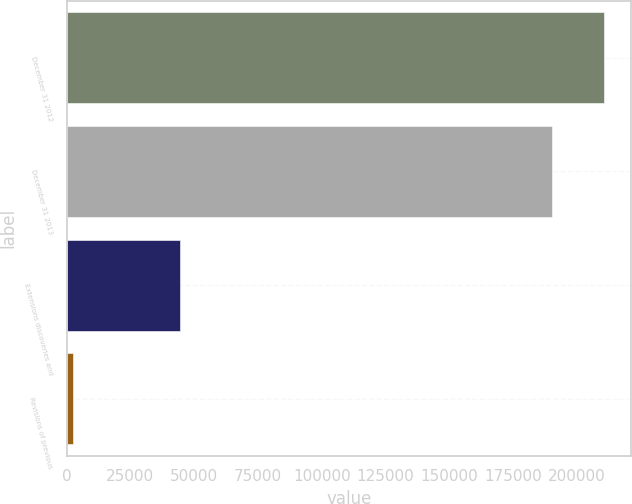<chart> <loc_0><loc_0><loc_500><loc_500><bar_chart><fcel>December 31 2012<fcel>December 31 2013<fcel>Extensions discoveries and<fcel>Revisions of previous<nl><fcel>210619<fcel>190355<fcel>44382<fcel>2413<nl></chart> 